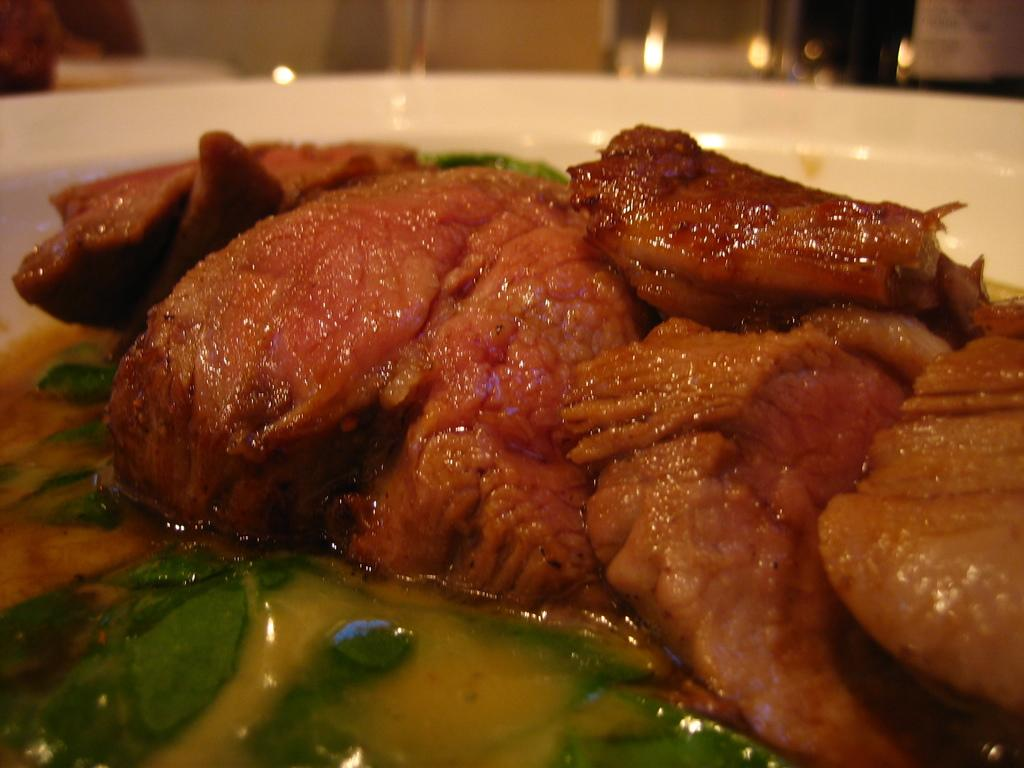What type of food can be seen in the image? There is food in the image, including flesh in a white bowl. What else is present in the image besides the food? There is soup at the bottom of the image and leaves are present. What type of hose can be seen connected to the elbow in the image? There is no hose or elbow present in the image; it only features food, soup, and leaves. 